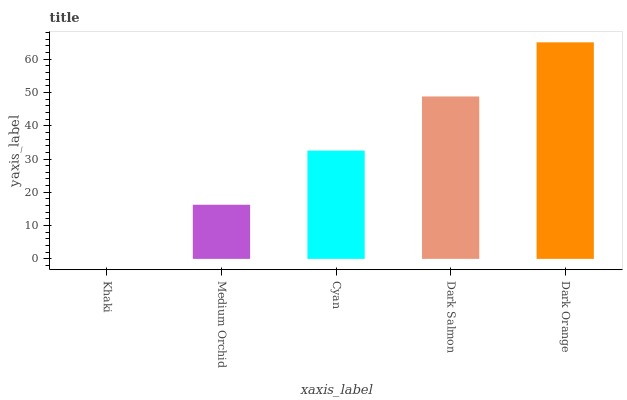Is Medium Orchid the minimum?
Answer yes or no. No. Is Medium Orchid the maximum?
Answer yes or no. No. Is Medium Orchid greater than Khaki?
Answer yes or no. Yes. Is Khaki less than Medium Orchid?
Answer yes or no. Yes. Is Khaki greater than Medium Orchid?
Answer yes or no. No. Is Medium Orchid less than Khaki?
Answer yes or no. No. Is Cyan the high median?
Answer yes or no. Yes. Is Cyan the low median?
Answer yes or no. Yes. Is Dark Salmon the high median?
Answer yes or no. No. Is Khaki the low median?
Answer yes or no. No. 